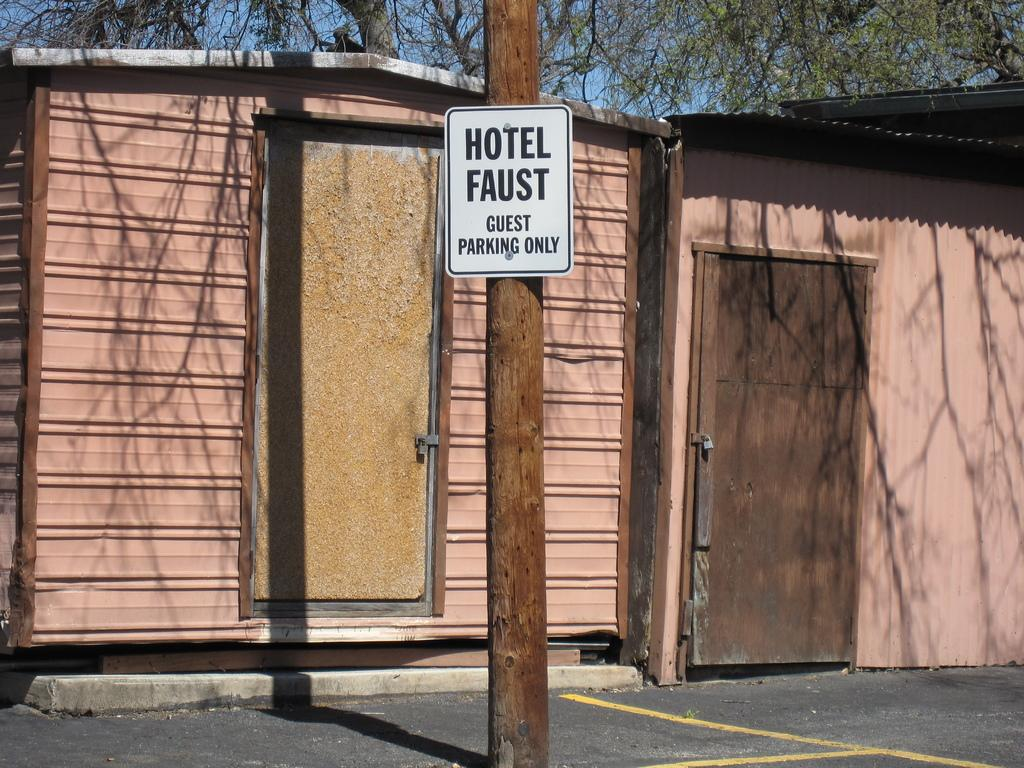How many houses can be seen in the image? There are two houses in the image. What is located in the center of the image? There is a pole in the center of the image. What is attached to the bottom of the pole? There is a board at the bottom of the pole. What type of pathway is visible in the image? There is a walkway in the image. What type of bells are hanging from the houses in the image? There are no bells hanging from the houses in the image. How does the pole provide support to the houses in the image? The pole does not provide support to the houses in the image; it is a separate object in the center of the image. 